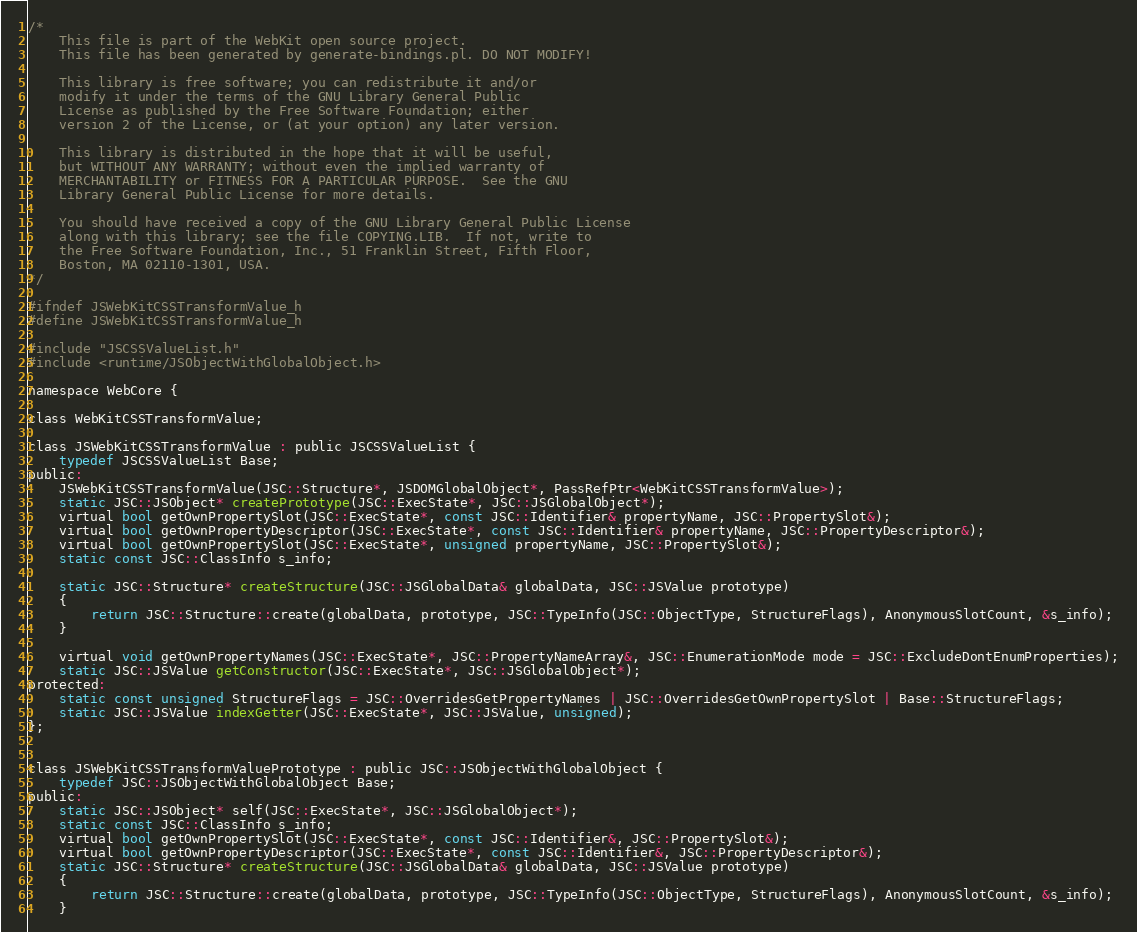Convert code to text. <code><loc_0><loc_0><loc_500><loc_500><_C_>/*
    This file is part of the WebKit open source project.
    This file has been generated by generate-bindings.pl. DO NOT MODIFY!

    This library is free software; you can redistribute it and/or
    modify it under the terms of the GNU Library General Public
    License as published by the Free Software Foundation; either
    version 2 of the License, or (at your option) any later version.

    This library is distributed in the hope that it will be useful,
    but WITHOUT ANY WARRANTY; without even the implied warranty of
    MERCHANTABILITY or FITNESS FOR A PARTICULAR PURPOSE.  See the GNU
    Library General Public License for more details.

    You should have received a copy of the GNU Library General Public License
    along with this library; see the file COPYING.LIB.  If not, write to
    the Free Software Foundation, Inc., 51 Franklin Street, Fifth Floor,
    Boston, MA 02110-1301, USA.
*/

#ifndef JSWebKitCSSTransformValue_h
#define JSWebKitCSSTransformValue_h

#include "JSCSSValueList.h"
#include <runtime/JSObjectWithGlobalObject.h>

namespace WebCore {

class WebKitCSSTransformValue;

class JSWebKitCSSTransformValue : public JSCSSValueList {
    typedef JSCSSValueList Base;
public:
    JSWebKitCSSTransformValue(JSC::Structure*, JSDOMGlobalObject*, PassRefPtr<WebKitCSSTransformValue>);
    static JSC::JSObject* createPrototype(JSC::ExecState*, JSC::JSGlobalObject*);
    virtual bool getOwnPropertySlot(JSC::ExecState*, const JSC::Identifier& propertyName, JSC::PropertySlot&);
    virtual bool getOwnPropertyDescriptor(JSC::ExecState*, const JSC::Identifier& propertyName, JSC::PropertyDescriptor&);
    virtual bool getOwnPropertySlot(JSC::ExecState*, unsigned propertyName, JSC::PropertySlot&);
    static const JSC::ClassInfo s_info;

    static JSC::Structure* createStructure(JSC::JSGlobalData& globalData, JSC::JSValue prototype)
    {
        return JSC::Structure::create(globalData, prototype, JSC::TypeInfo(JSC::ObjectType, StructureFlags), AnonymousSlotCount, &s_info);
    }

    virtual void getOwnPropertyNames(JSC::ExecState*, JSC::PropertyNameArray&, JSC::EnumerationMode mode = JSC::ExcludeDontEnumProperties);
    static JSC::JSValue getConstructor(JSC::ExecState*, JSC::JSGlobalObject*);
protected:
    static const unsigned StructureFlags = JSC::OverridesGetPropertyNames | JSC::OverridesGetOwnPropertySlot | Base::StructureFlags;
    static JSC::JSValue indexGetter(JSC::ExecState*, JSC::JSValue, unsigned);
};


class JSWebKitCSSTransformValuePrototype : public JSC::JSObjectWithGlobalObject {
    typedef JSC::JSObjectWithGlobalObject Base;
public:
    static JSC::JSObject* self(JSC::ExecState*, JSC::JSGlobalObject*);
    static const JSC::ClassInfo s_info;
    virtual bool getOwnPropertySlot(JSC::ExecState*, const JSC::Identifier&, JSC::PropertySlot&);
    virtual bool getOwnPropertyDescriptor(JSC::ExecState*, const JSC::Identifier&, JSC::PropertyDescriptor&);
    static JSC::Structure* createStructure(JSC::JSGlobalData& globalData, JSC::JSValue prototype)
    {
        return JSC::Structure::create(globalData, prototype, JSC::TypeInfo(JSC::ObjectType, StructureFlags), AnonymousSlotCount, &s_info);
    }</code> 